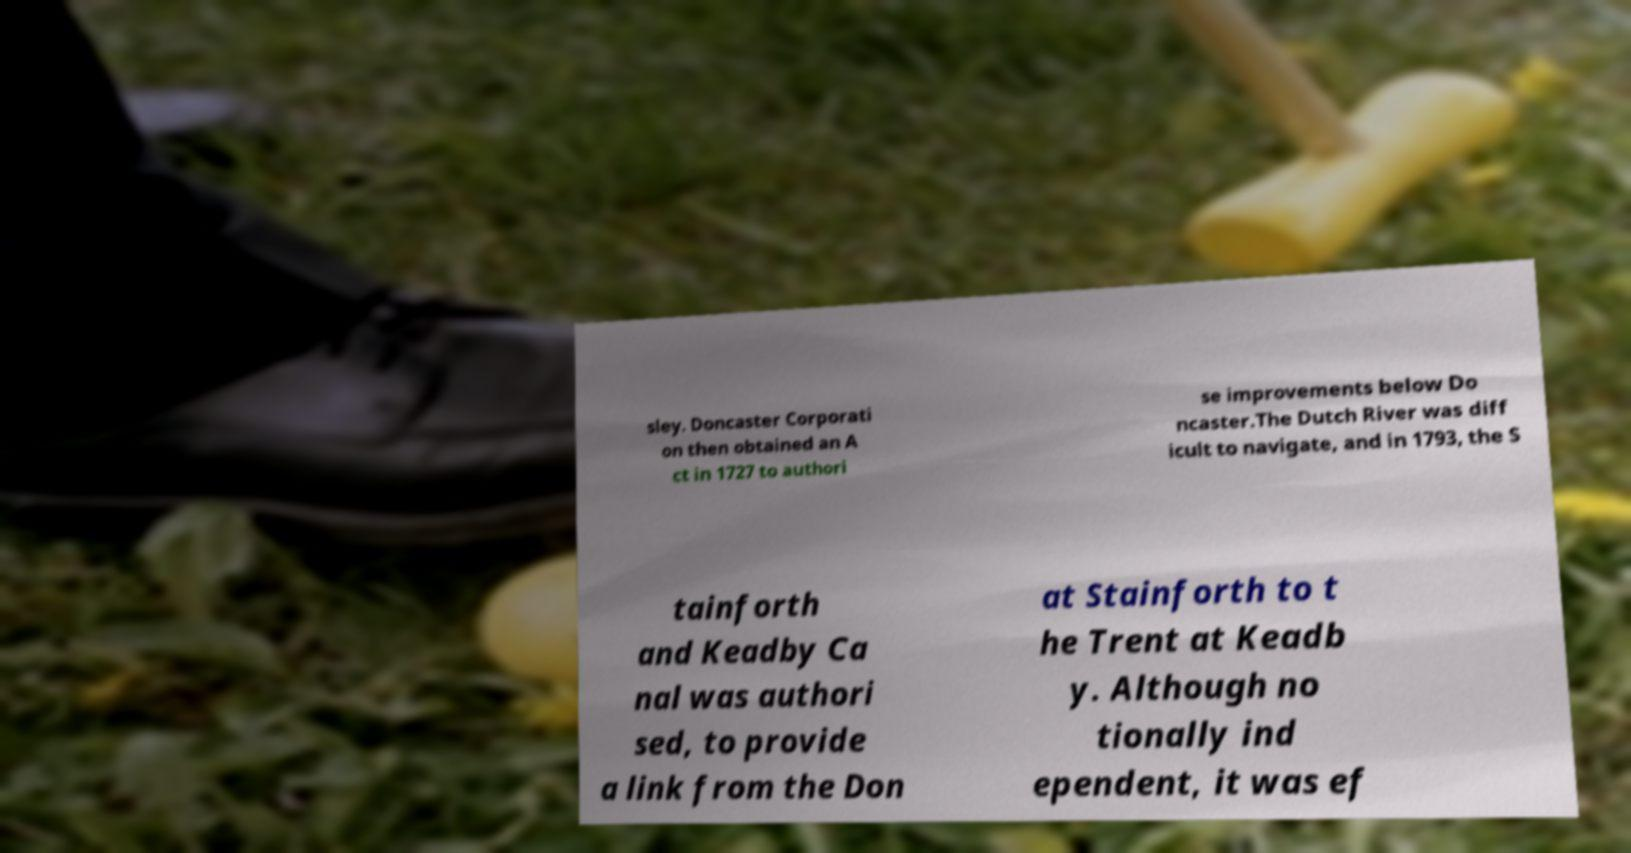Please read and relay the text visible in this image. What does it say? sley. Doncaster Corporati on then obtained an A ct in 1727 to authori se improvements below Do ncaster.The Dutch River was diff icult to navigate, and in 1793, the S tainforth and Keadby Ca nal was authori sed, to provide a link from the Don at Stainforth to t he Trent at Keadb y. Although no tionally ind ependent, it was ef 